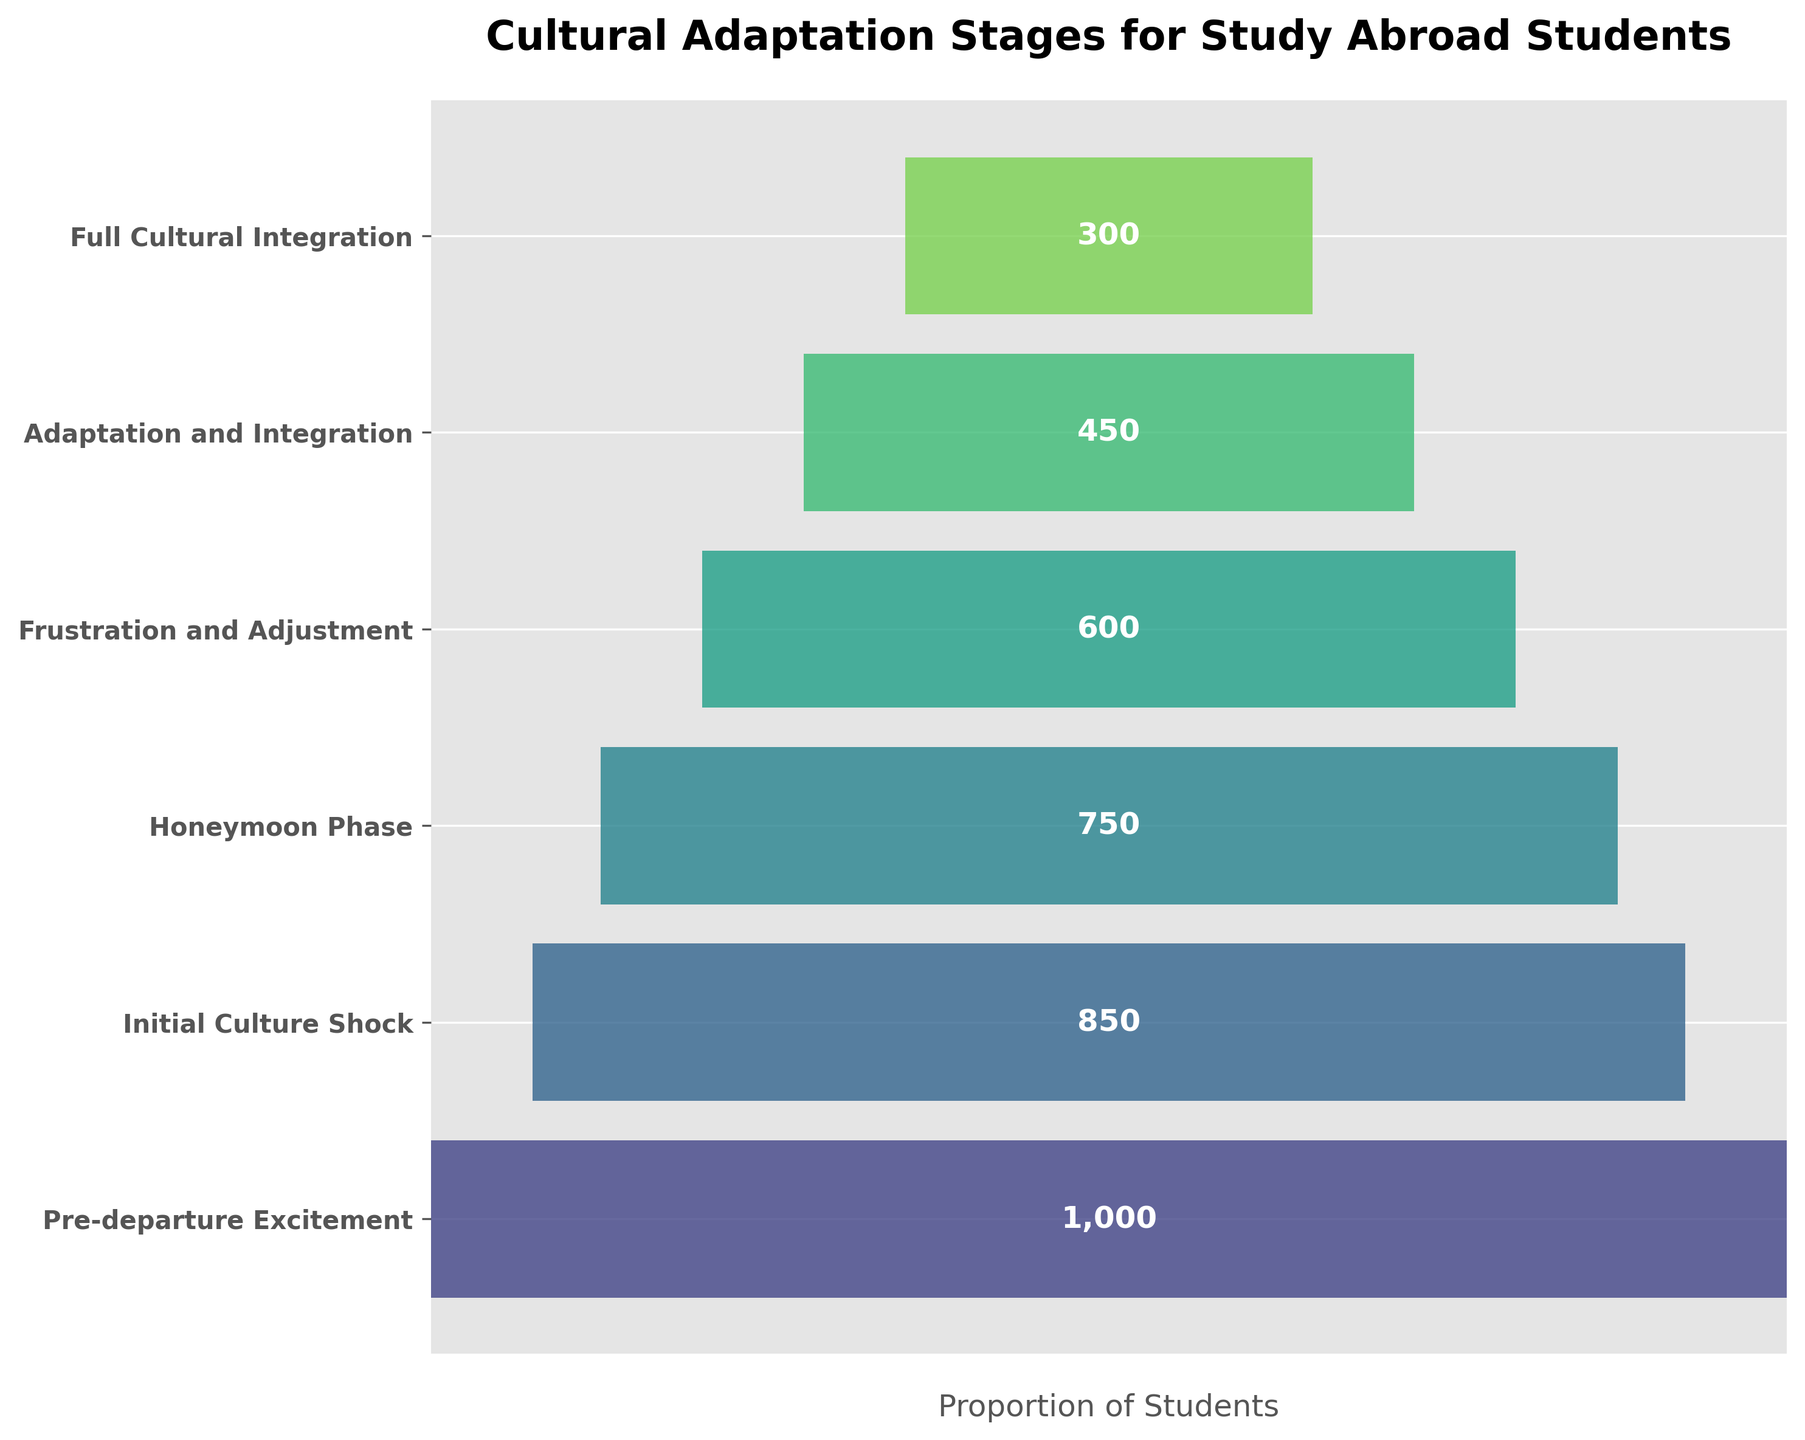How many stages of cultural adaptation are represented in the figure? The funnel chart contains different colored horizontal bars that represent each stage of cultural adaptation. By counting these bars, you can determine the number of stages.
Answer: 6 What is the title of the figure? The title of the figure is usually located at the top and provides a summary of what the chart represents.
Answer: Cultural Adaptation Stages for Study Abroad Students Which stage has the highest number of students? By observing the length of the bars in the funnel chart, the widest bar represents the stage with the most students.
Answer: Pre-departure Excitement Which stage experiences the biggest drop in student numbers compared to the previous stage? To find this, compare the changes in student numbers between consecutive stages and identify the largest decrease. The drop from 'Initial Culture Shock' to 'Honeymoon Phase' is (850 - 750) = 100, 'Honeymoon Phase' to 'Frustration and Adjustment' is (750 - 600) = 150, and so on.
Answer: Honeymoon Phase to Frustration and Adjustment What is the combined total number of students from the 'Frustration and Adjustment' and 'Adaptation and Integration' stages? To find this, sum the student numbers from these two stages: 600 + 450.
Answer: 1050 How does the number of students who reach 'Full Cultural Integration' compare to those in the 'Honeymoon Phase'? Compare the lengths of the bars for these stages to see which is larger and by how much. The difference is (750 - 300) = 450.
Answer: 450 fewer students What percentage of students experience 'Initial Culture Shock' after 'Pre-departure Excitement'? To determine this, divide the number of students in the 'Initial Culture Shock' by the number in 'Pre-departure Excitement' and multiply by 100: (850 / 1000) * 100 = 85%.
Answer: 85% Which has fewer students: 'Frustration and Adjustment' or 'Full Cultural Integration'? By comparing the lengths of the bars, you can see which stage has fewer students.
Answer: Full Cultural Integration What does the axis represent in this funnel chart? The horizontal axis, though not explicitly labeled with values, represents the proportion of students at each stage.
Answer: Proportion of Students What is the difference in the number of students between 'Adaptation and Integration' and 'Full Cultural Integration'? Calculate the difference between the numbers of students in these two stages: 450 - 300.
Answer: 150 